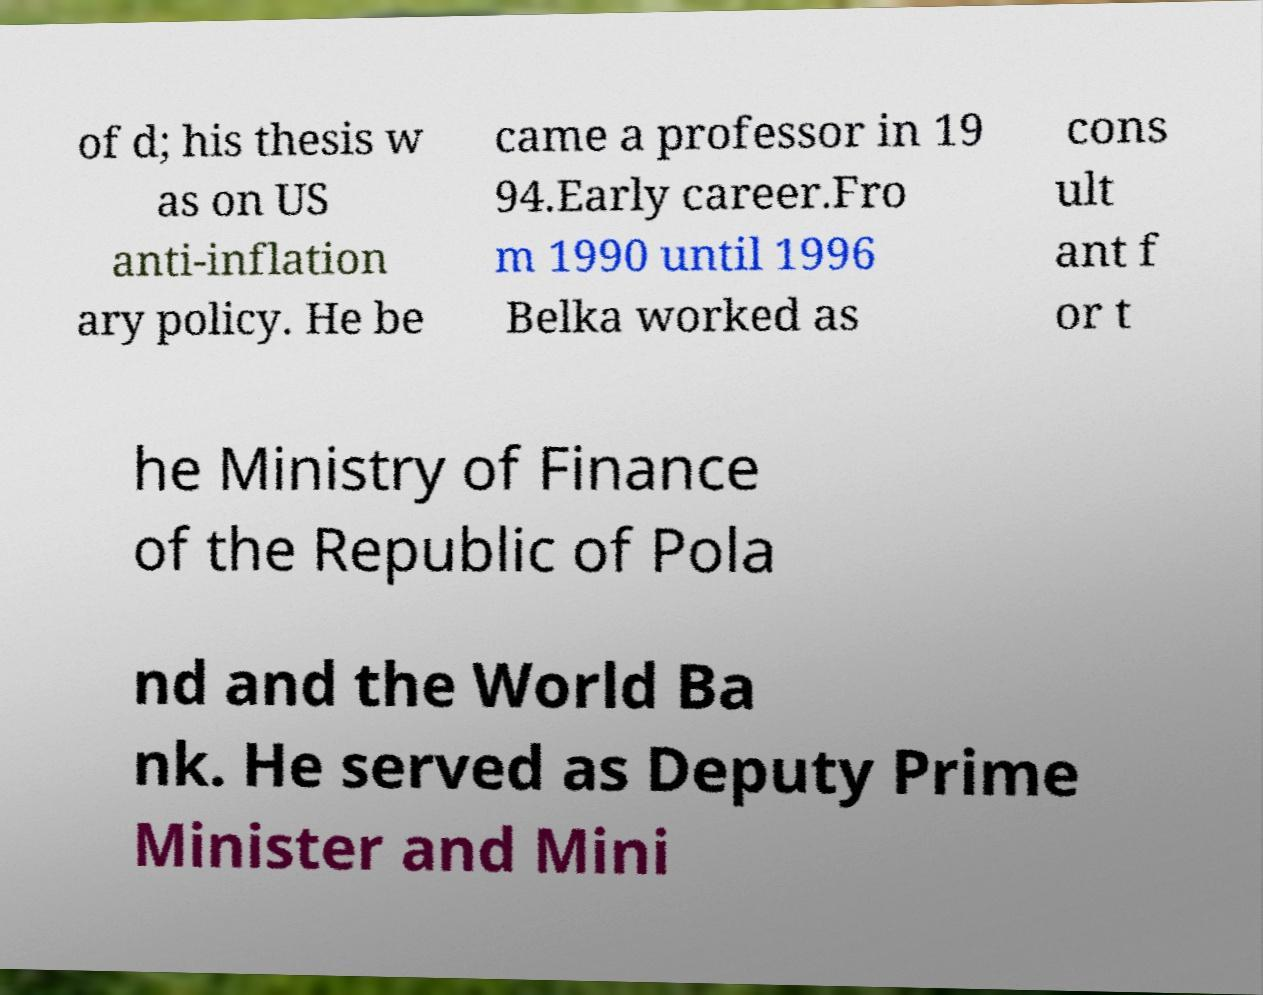Could you assist in decoding the text presented in this image and type it out clearly? of d; his thesis w as on US anti-inflation ary policy. He be came a professor in 19 94.Early career.Fro m 1990 until 1996 Belka worked as cons ult ant f or t he Ministry of Finance of the Republic of Pola nd and the World Ba nk. He served as Deputy Prime Minister and Mini 